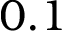Convert formula to latex. <formula><loc_0><loc_0><loc_500><loc_500>0 . 1</formula> 